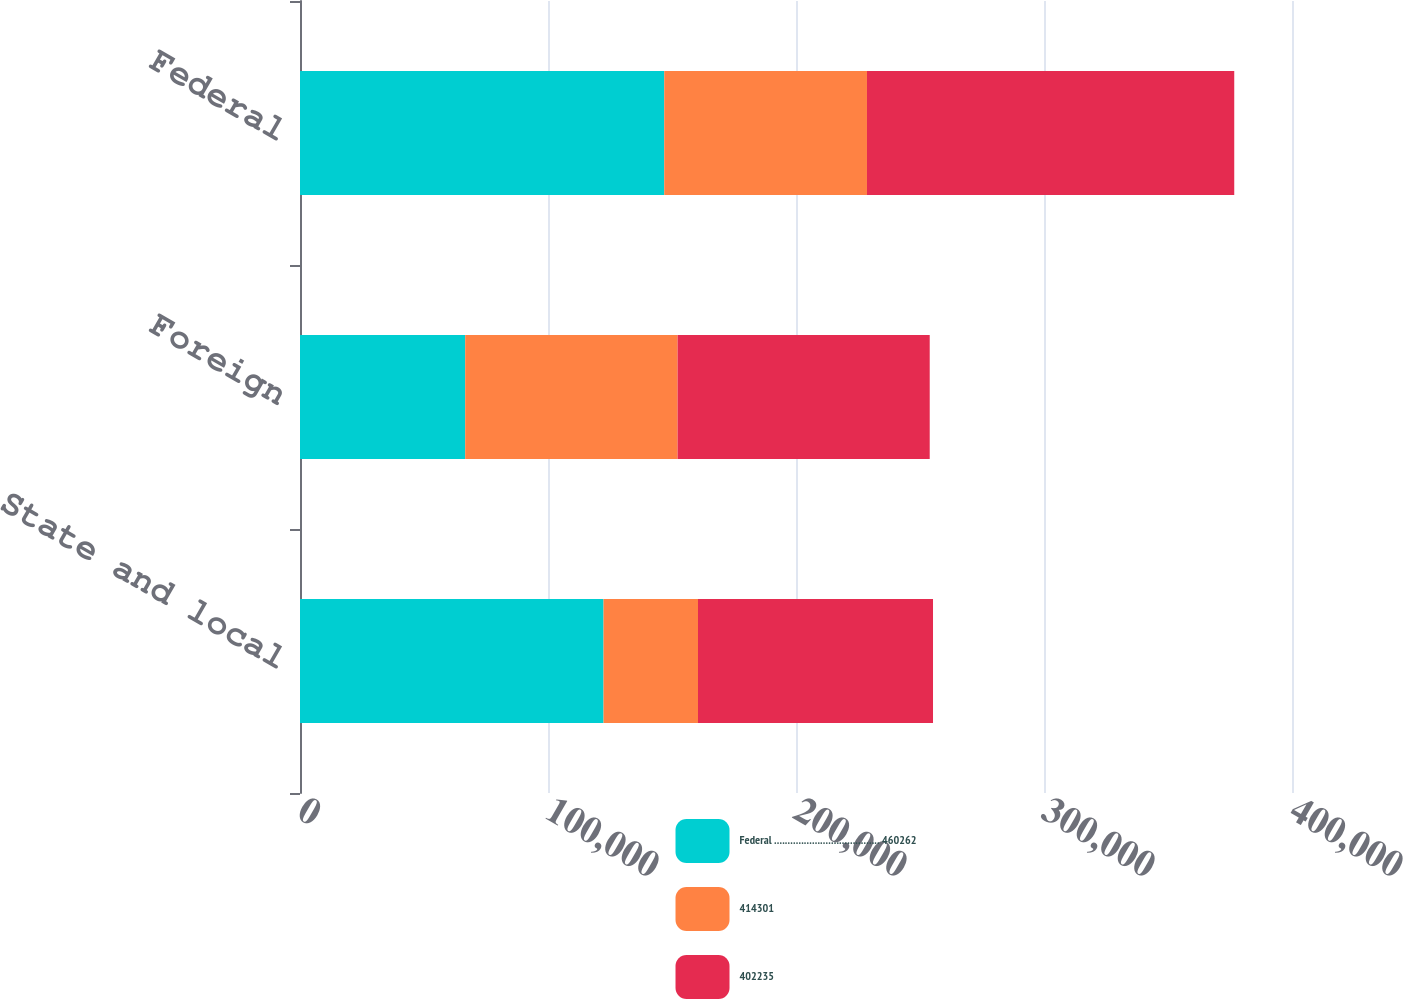Convert chart to OTSL. <chart><loc_0><loc_0><loc_500><loc_500><stacked_bar_chart><ecel><fcel>State and local<fcel>Foreign<fcel>Federal<nl><fcel>Federal ....................................... 460262<fcel>122396<fcel>66610<fcel>146872<nl><fcel>414301<fcel>38087<fcel>85649<fcel>81745<nl><fcel>402235<fcel>94763<fcel>101662<fcel>148094<nl></chart> 